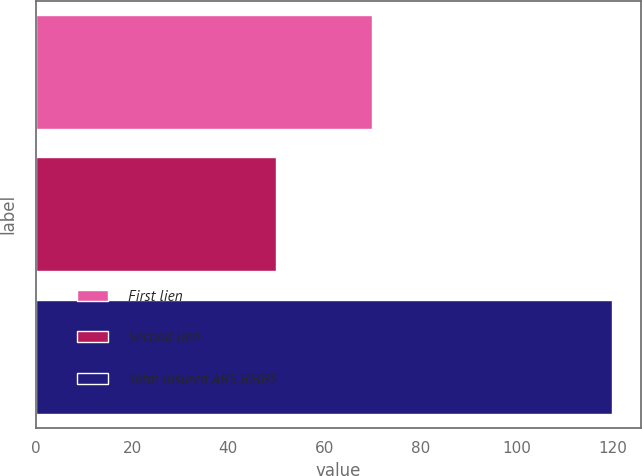<chart> <loc_0><loc_0><loc_500><loc_500><bar_chart><fcel>First lien<fcel>Second lien<fcel>Total insured ABS RMBS<nl><fcel>70<fcel>50<fcel>120<nl></chart> 